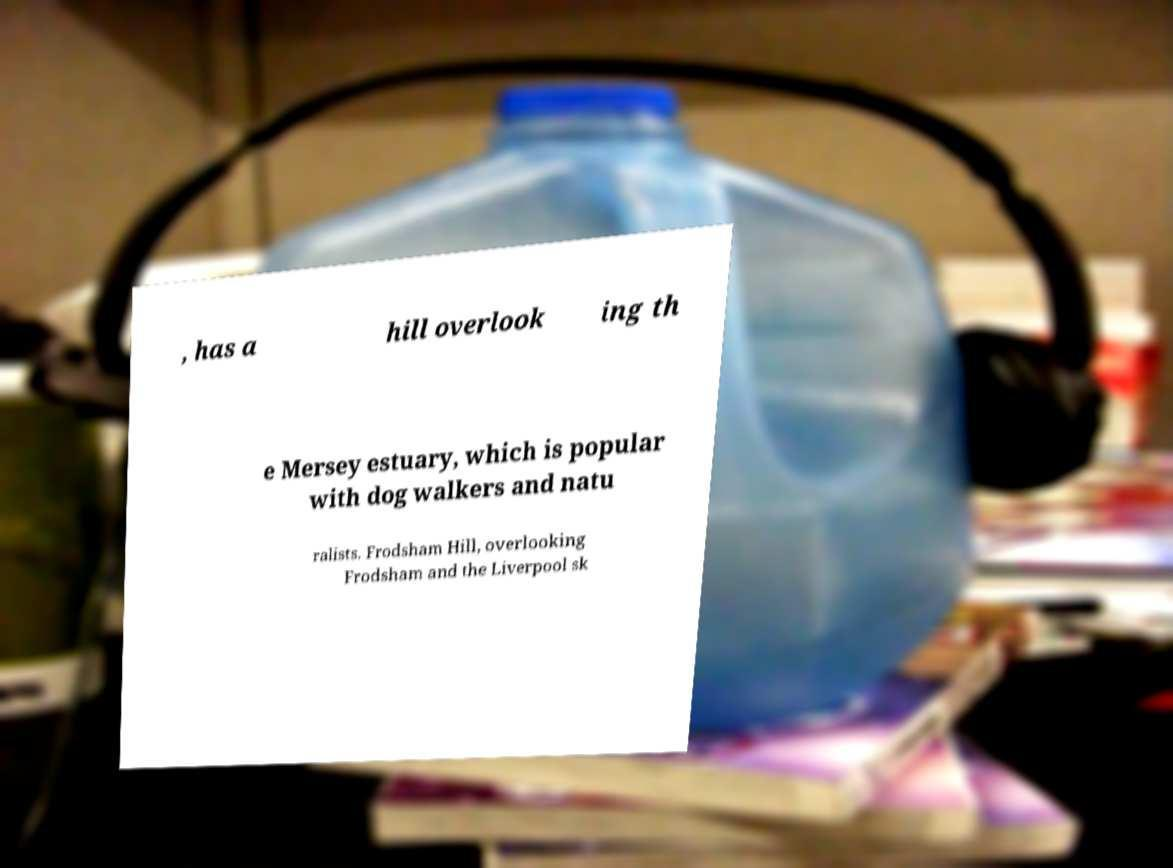I need the written content from this picture converted into text. Can you do that? , has a hill overlook ing th e Mersey estuary, which is popular with dog walkers and natu ralists. Frodsham Hill, overlooking Frodsham and the Liverpool sk 